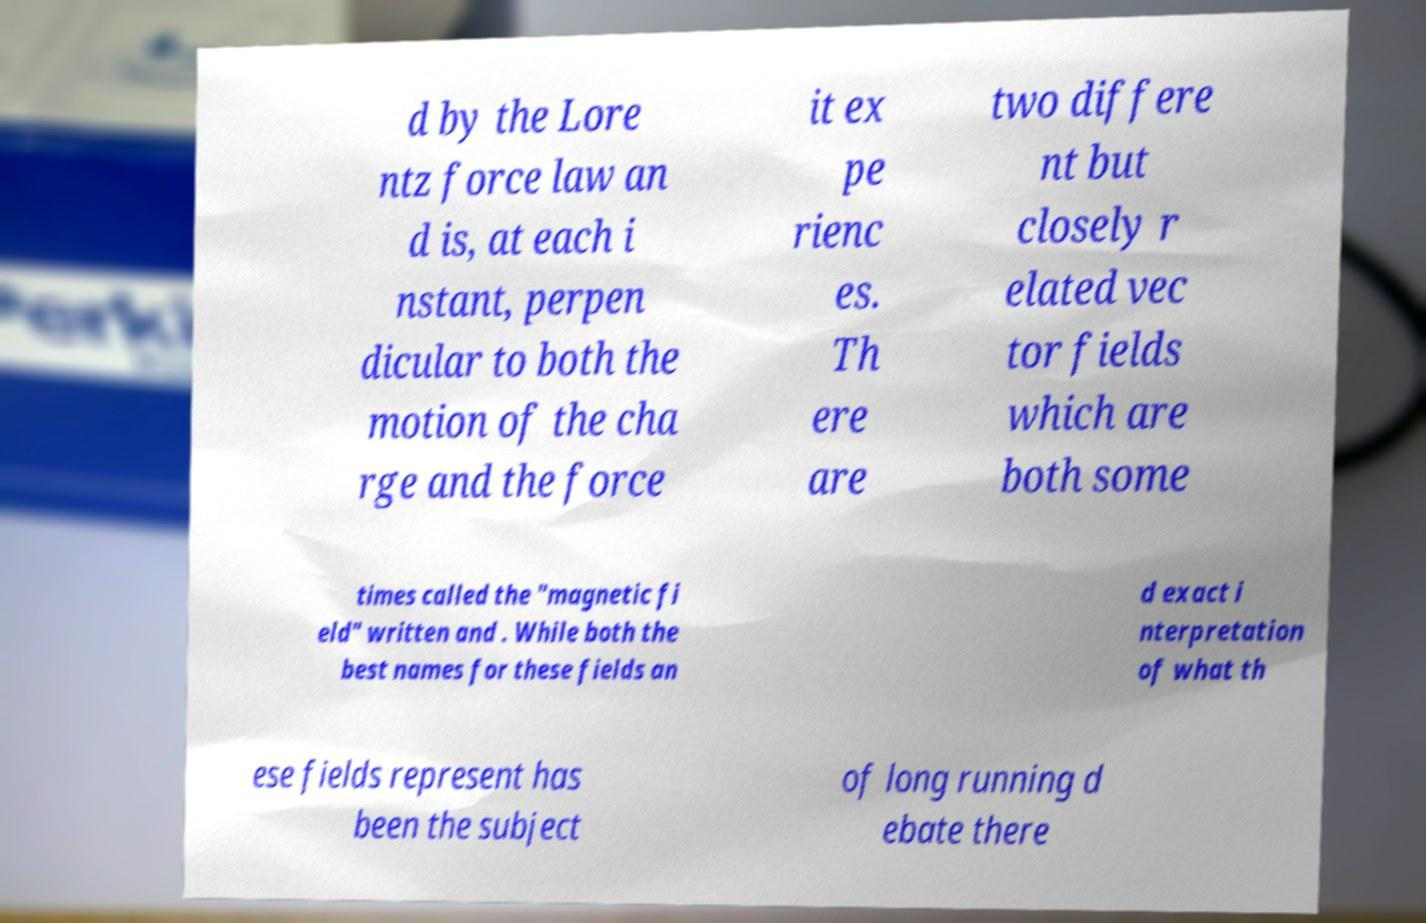There's text embedded in this image that I need extracted. Can you transcribe it verbatim? d by the Lore ntz force law an d is, at each i nstant, perpen dicular to both the motion of the cha rge and the force it ex pe rienc es. Th ere are two differe nt but closely r elated vec tor fields which are both some times called the "magnetic fi eld" written and . While both the best names for these fields an d exact i nterpretation of what th ese fields represent has been the subject of long running d ebate there 